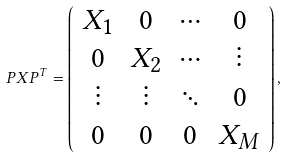<formula> <loc_0><loc_0><loc_500><loc_500>P X P ^ { T } = \left ( \begin{array} { c c c c } X _ { 1 } & 0 & \cdots & 0 \\ 0 & X _ { 2 } & \cdots & \vdots \\ \vdots & \vdots & \ddots & 0 \\ 0 & 0 & 0 & X _ { M } \\ \end{array} \right ) ,</formula> 